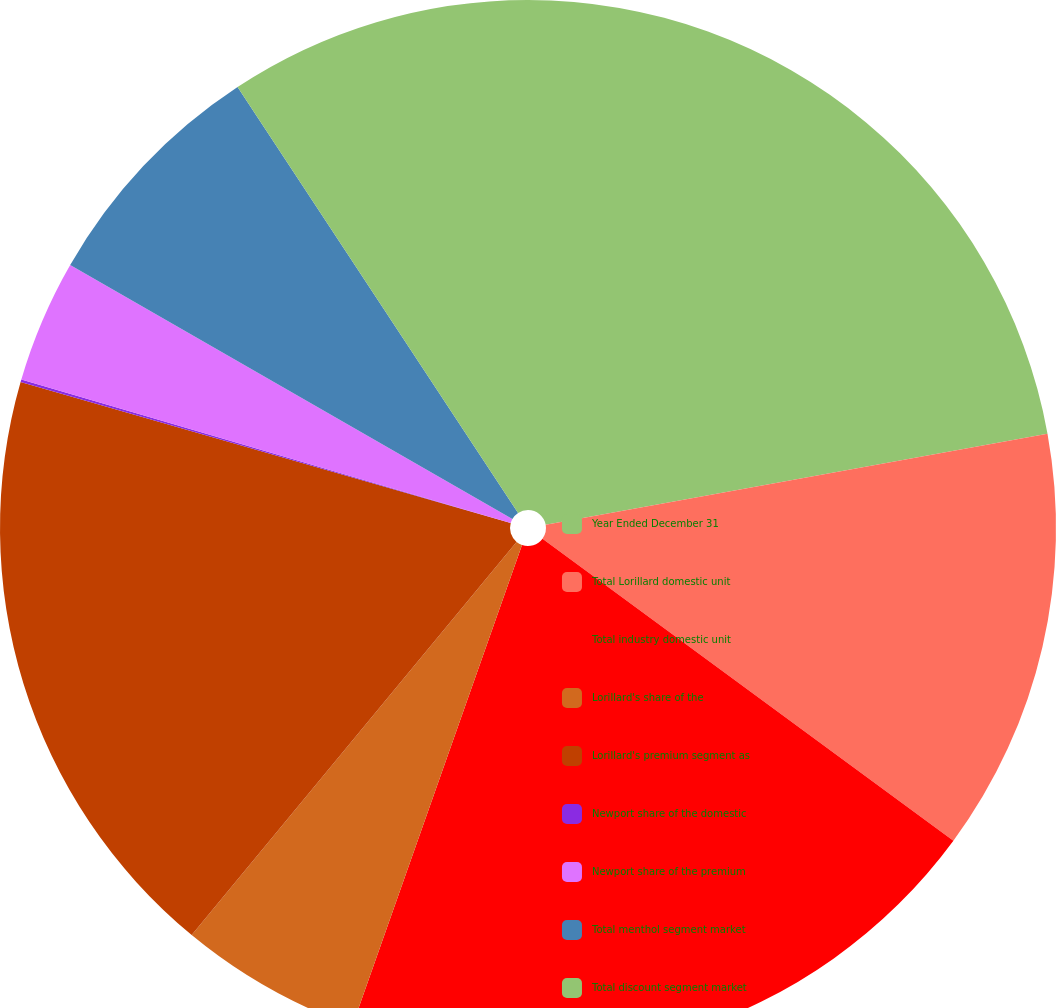Convert chart to OTSL. <chart><loc_0><loc_0><loc_500><loc_500><pie_chart><fcel>Year Ended December 31<fcel>Total Lorillard domestic unit<fcel>Total industry domestic unit<fcel>Lorillard's share of the<fcel>Lorillard's premium segment as<fcel>Newport share of the domestic<fcel>Newport share of the premium<fcel>Total menthol segment market<fcel>Total discount segment market<nl><fcel>22.14%<fcel>12.95%<fcel>20.31%<fcel>5.59%<fcel>18.47%<fcel>0.08%<fcel>3.76%<fcel>7.43%<fcel>9.27%<nl></chart> 